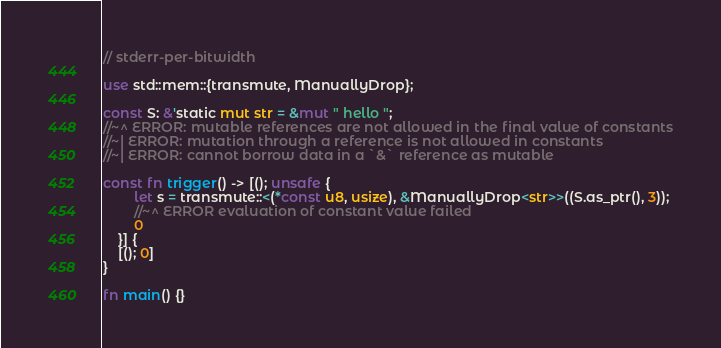<code> <loc_0><loc_0><loc_500><loc_500><_Rust_>// stderr-per-bitwidth

use std::mem::{transmute, ManuallyDrop};

const S: &'static mut str = &mut " hello ";
//~^ ERROR: mutable references are not allowed in the final value of constants
//~| ERROR: mutation through a reference is not allowed in constants
//~| ERROR: cannot borrow data in a `&` reference as mutable

const fn trigger() -> [(); unsafe {
        let s = transmute::<(*const u8, usize), &ManuallyDrop<str>>((S.as_ptr(), 3));
        //~^ ERROR evaluation of constant value failed
        0
    }] {
    [(); 0]
}

fn main() {}
</code> 